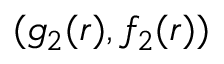Convert formula to latex. <formula><loc_0><loc_0><loc_500><loc_500>( g _ { 2 } ( r ) , f _ { 2 } ( r ) )</formula> 